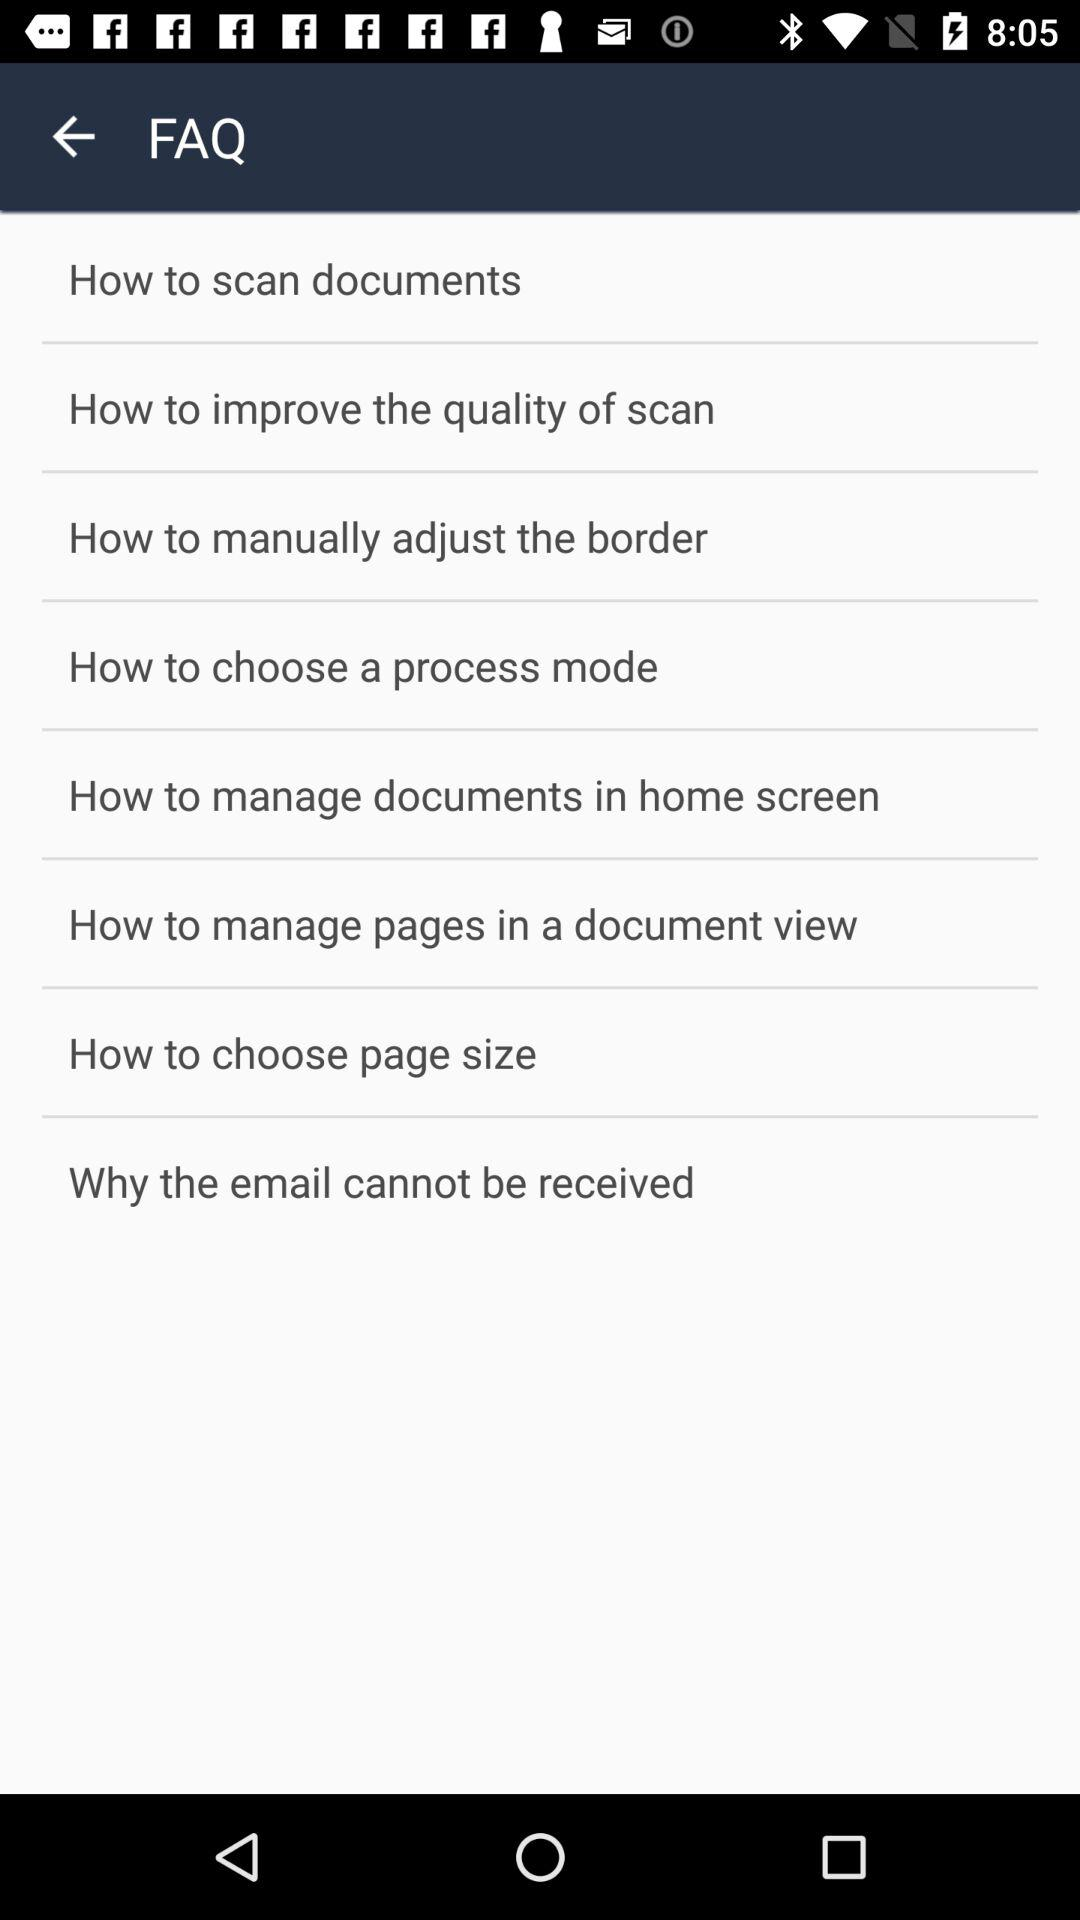How many FAQs are there on this page?
Answer the question using a single word or phrase. 8 